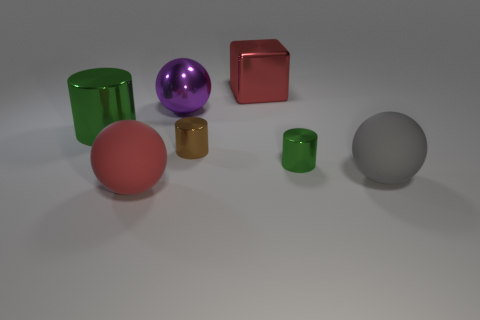Add 2 tiny blue rubber cylinders. How many objects exist? 9 Subtract all blocks. How many objects are left? 6 Add 7 red things. How many red things are left? 9 Add 5 large green rubber objects. How many large green rubber objects exist? 5 Subtract 1 brown cylinders. How many objects are left? 6 Subtract all metallic cylinders. Subtract all balls. How many objects are left? 1 